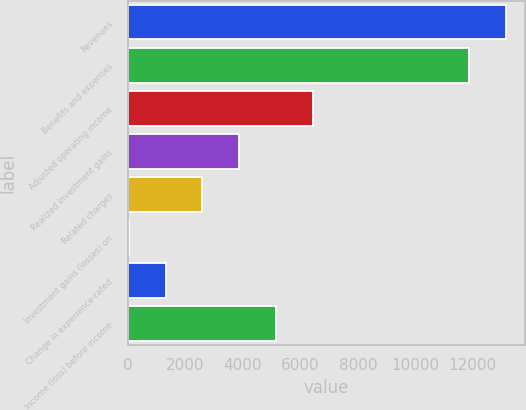<chart> <loc_0><loc_0><loc_500><loc_500><bar_chart><fcel>Revenues<fcel>Benefits and expenses<fcel>Adjusted operating income<fcel>Realized investment gains<fcel>Related charges<fcel>Investment gains (losses) on<fcel>Change in experience-rated<fcel>Income (loss) before income<nl><fcel>13149.5<fcel>11864<fcel>6448.5<fcel>3877.5<fcel>2592<fcel>21<fcel>1306.5<fcel>5163<nl></chart> 